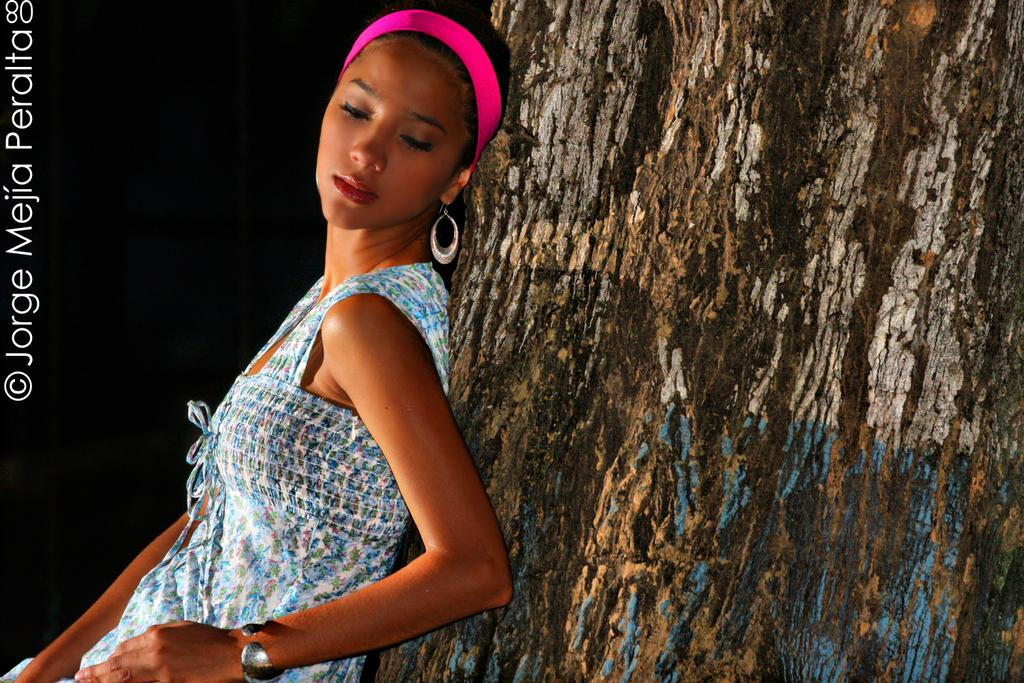Who is present in the image? There is a woman in the image. What object can be seen in the image besides the woman? There is a tree trunk in the image. How would you describe the overall lighting in the image? The background of the image is dark. What can be found on the left side of the image? There is a number and text on the left side of the image. What type of bucket is being used by the woman to cook in the image? There is no bucket or cooking activity present in the image. 